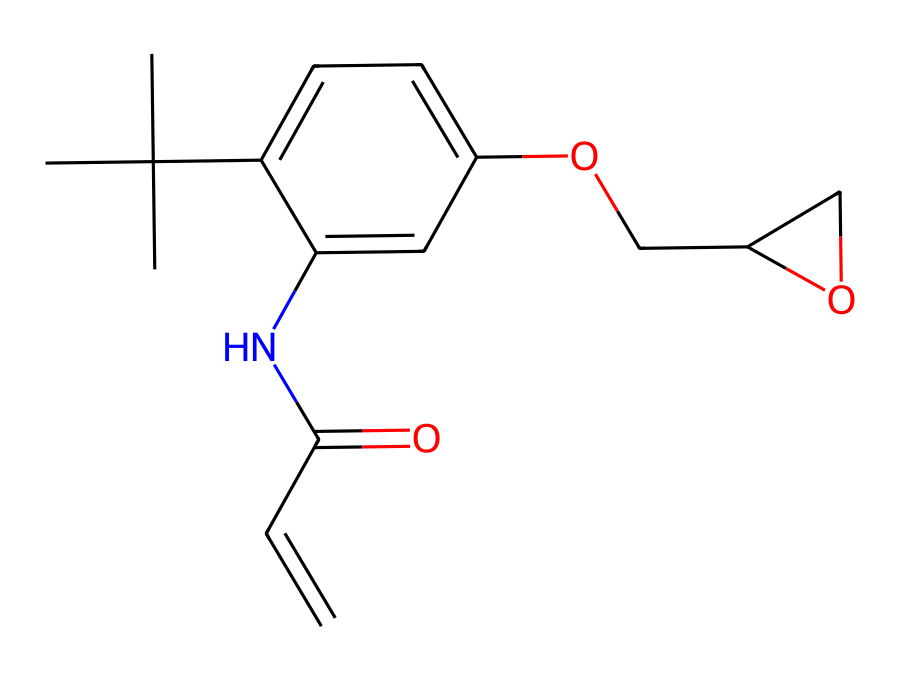How many carbon atoms are in the molecular structure? Counting the carbon (C) atoms in the SMILES notation, there are 13 carbon atoms present in the structure.
Answer: 13 What functional groups are present in this photoresist? The chemical structure contains an alcohol (–OH) group, an amide (–C(=O)N–) group, and an alkene (C=C) group.
Answer: alcohol, amide, alkene What type of reaction mechanism could this photoresist undergo upon exposure to light? The presence of the double bond suggests that it may undergo a cross-linking reaction upon exposure to light, a typical behavior of negative photoresists where it reacts to UV radiation leading to polymerization.
Answer: cross-linking How does the presence of the amide group affect the durability of this photoresist? The amide group can enhance adhesion and thermal stability due to its ability to form hydrogen bonds, contributing to the overall durability of the photoresist.
Answer: enhances adhesion What is the significance of the epoxy in this photoresist? The epoxy structure is known for providing excellent mechanical strength and chemical resistance, contributing to the durability and performance of the photoresist in fabrication processes.
Answer: mechanical strength Which part of the molecule is primarily responsible for its photoreactive properties? The alkene portion of the molecule is primarily responsible due to its ability to undergo photochemical reactions, essential for the photoresist action when exposed to light.
Answer: alkene 